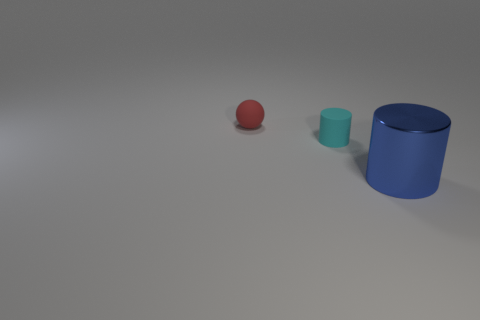Add 1 blue cylinders. How many objects exist? 4 Subtract all blue cylinders. How many cylinders are left? 1 Subtract 1 cylinders. How many cylinders are left? 1 Subtract 0 purple blocks. How many objects are left? 3 Subtract all cylinders. How many objects are left? 1 Subtract all blue cylinders. Subtract all purple cubes. How many cylinders are left? 1 Subtract all blue balls. How many green cylinders are left? 0 Subtract all big blue shiny things. Subtract all large balls. How many objects are left? 2 Add 3 blue metallic cylinders. How many blue metallic cylinders are left? 4 Add 1 blue shiny cylinders. How many blue shiny cylinders exist? 2 